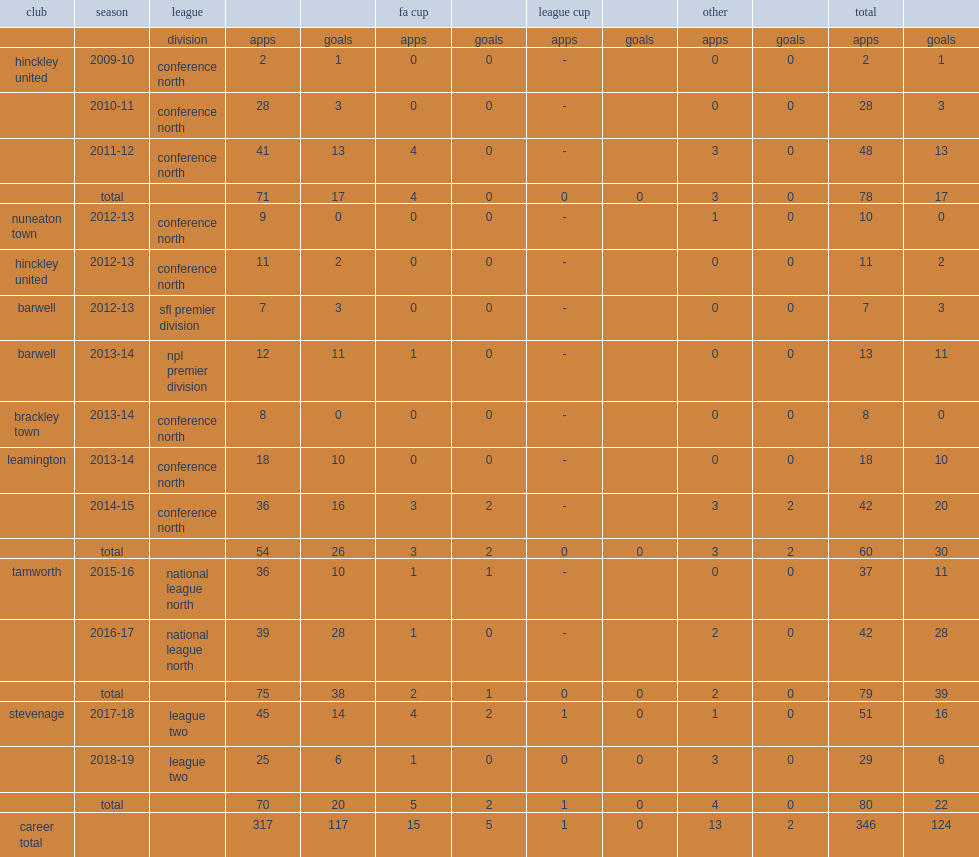Which club did newton play for in 2013-14? Leamington. 